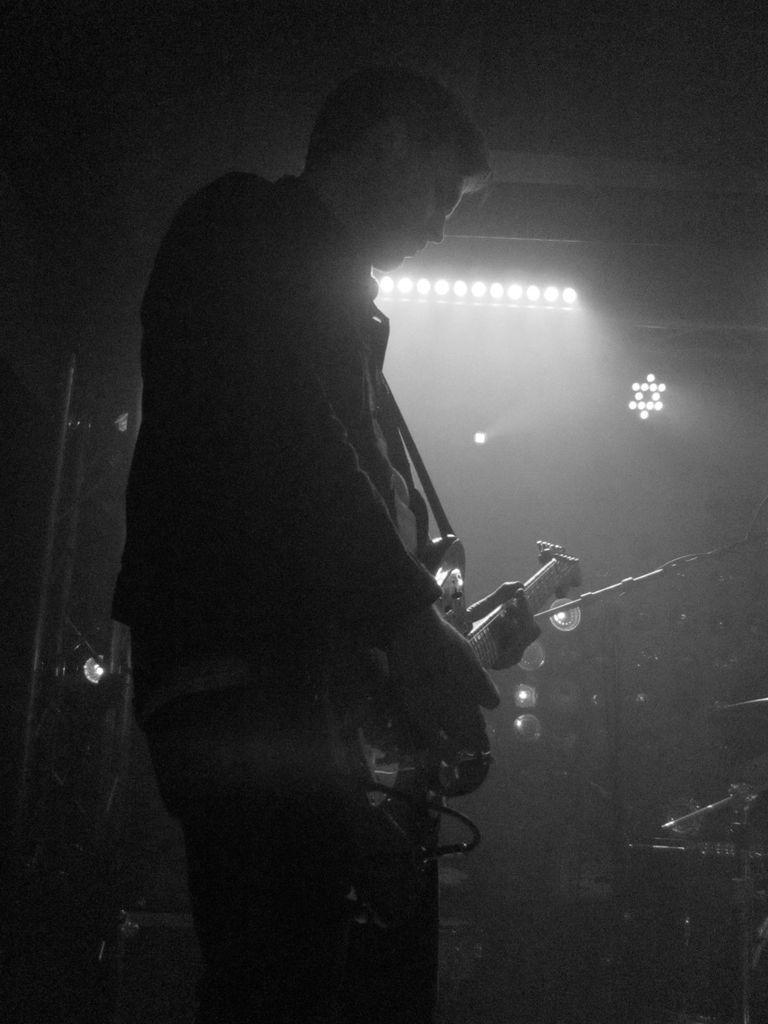What is the man in the image doing? The man is playing a guitar in the image. What can be seen in the man's hands? The man is holding a guitar in his hands. What else is visible in the image besides the man and the guitar? There are lights present in the image. What type of spoon is the man using to play the guitar in the image? There is no spoon present in the image, and the man is not using any utensils to play the guitar. 